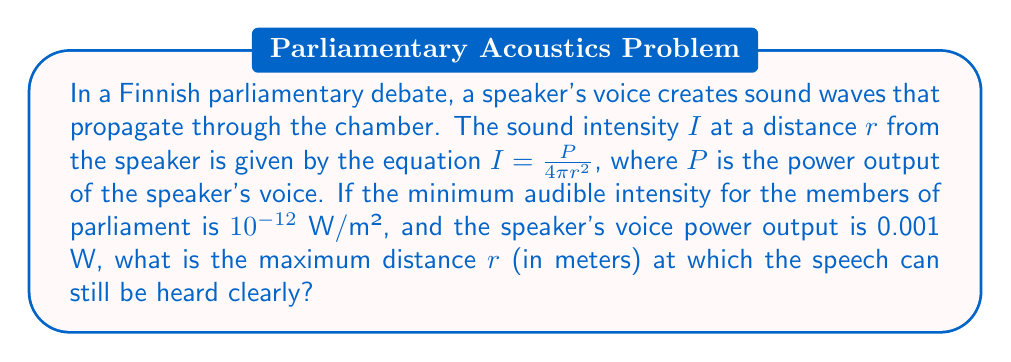What is the answer to this math problem? To solve this problem, we'll follow these steps:

1) We're given the equation for sound intensity:
   $$I = \frac{P}{4\pi r^2}$$

2) We know:
   - $P = 0.001$ W (power output of the speaker's voice)
   - $I = 10^{-12}$ W/m² (minimum audible intensity)

3) We need to solve for $r$. Let's substitute the known values into the equation:

   $$10^{-12} = \frac{0.001}{4\pi r^2}$$

4) Multiply both sides by $4\pi r^2$:

   $$4\pi r^2 \cdot 10^{-12} = 0.001$$

5) Divide both sides by $4\pi \cdot 10^{-12}$:

   $$r^2 = \frac{0.001}{4\pi \cdot 10^{-12}} = \frac{10^{-3}}{4\pi \cdot 10^{-12}} = \frac{10^9}{4\pi}$$

6) Take the square root of both sides:

   $$r = \sqrt{\frac{10^9}{4\pi}} \approx 8912.5$$

Therefore, the maximum distance at which the speech can still be heard clearly is approximately 8912.5 meters.
Answer: 8912.5 m 